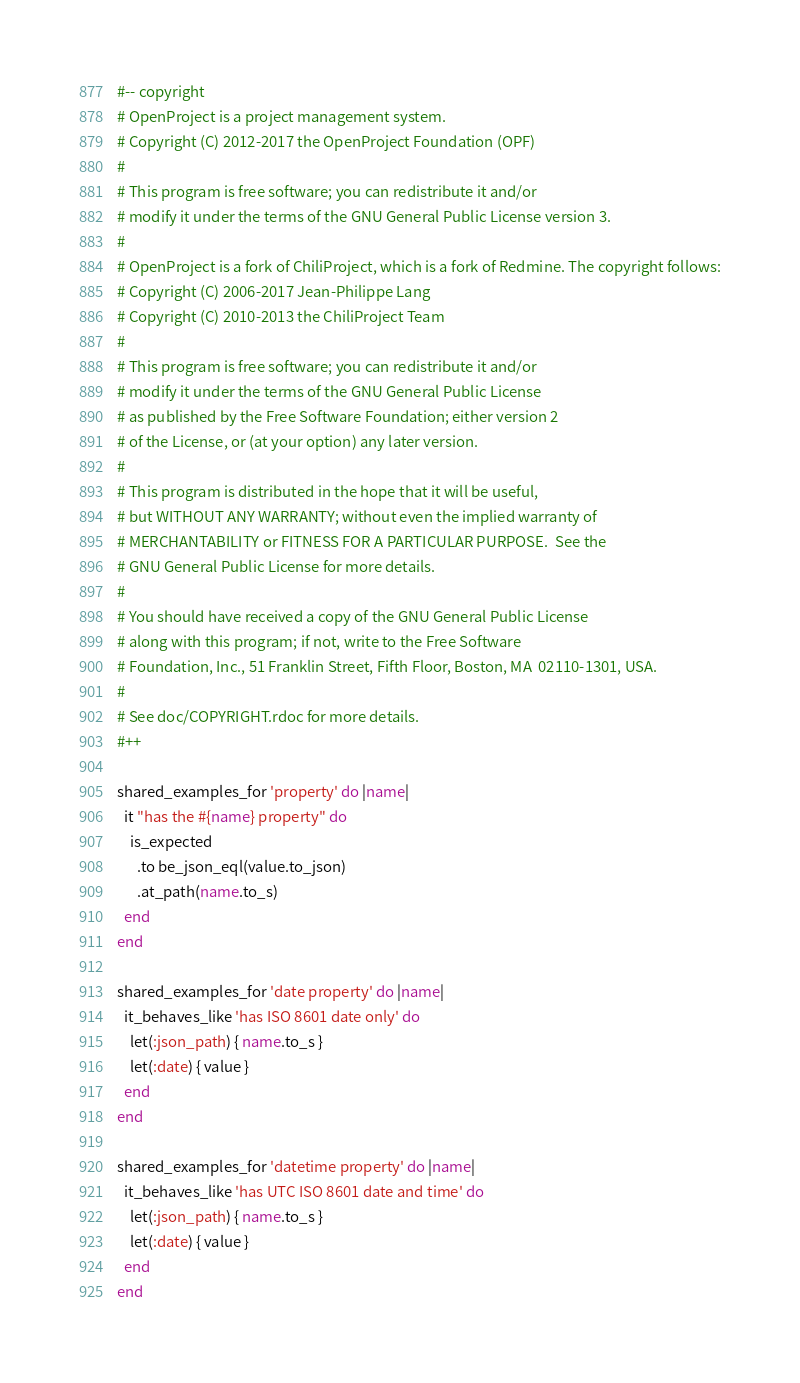<code> <loc_0><loc_0><loc_500><loc_500><_Ruby_>#-- copyright
# OpenProject is a project management system.
# Copyright (C) 2012-2017 the OpenProject Foundation (OPF)
#
# This program is free software; you can redistribute it and/or
# modify it under the terms of the GNU General Public License version 3.
#
# OpenProject is a fork of ChiliProject, which is a fork of Redmine. The copyright follows:
# Copyright (C) 2006-2017 Jean-Philippe Lang
# Copyright (C) 2010-2013 the ChiliProject Team
#
# This program is free software; you can redistribute it and/or
# modify it under the terms of the GNU General Public License
# as published by the Free Software Foundation; either version 2
# of the License, or (at your option) any later version.
#
# This program is distributed in the hope that it will be useful,
# but WITHOUT ANY WARRANTY; without even the implied warranty of
# MERCHANTABILITY or FITNESS FOR A PARTICULAR PURPOSE.  See the
# GNU General Public License for more details.
#
# You should have received a copy of the GNU General Public License
# along with this program; if not, write to the Free Software
# Foundation, Inc., 51 Franklin Street, Fifth Floor, Boston, MA  02110-1301, USA.
#
# See doc/COPYRIGHT.rdoc for more details.
#++

shared_examples_for 'property' do |name|
  it "has the #{name} property" do
    is_expected
      .to be_json_eql(value.to_json)
      .at_path(name.to_s)
  end
end

shared_examples_for 'date property' do |name|
  it_behaves_like 'has ISO 8601 date only' do
    let(:json_path) { name.to_s }
    let(:date) { value }
  end
end

shared_examples_for 'datetime property' do |name|
  it_behaves_like 'has UTC ISO 8601 date and time' do
    let(:json_path) { name.to_s }
    let(:date) { value }
  end
end
</code> 